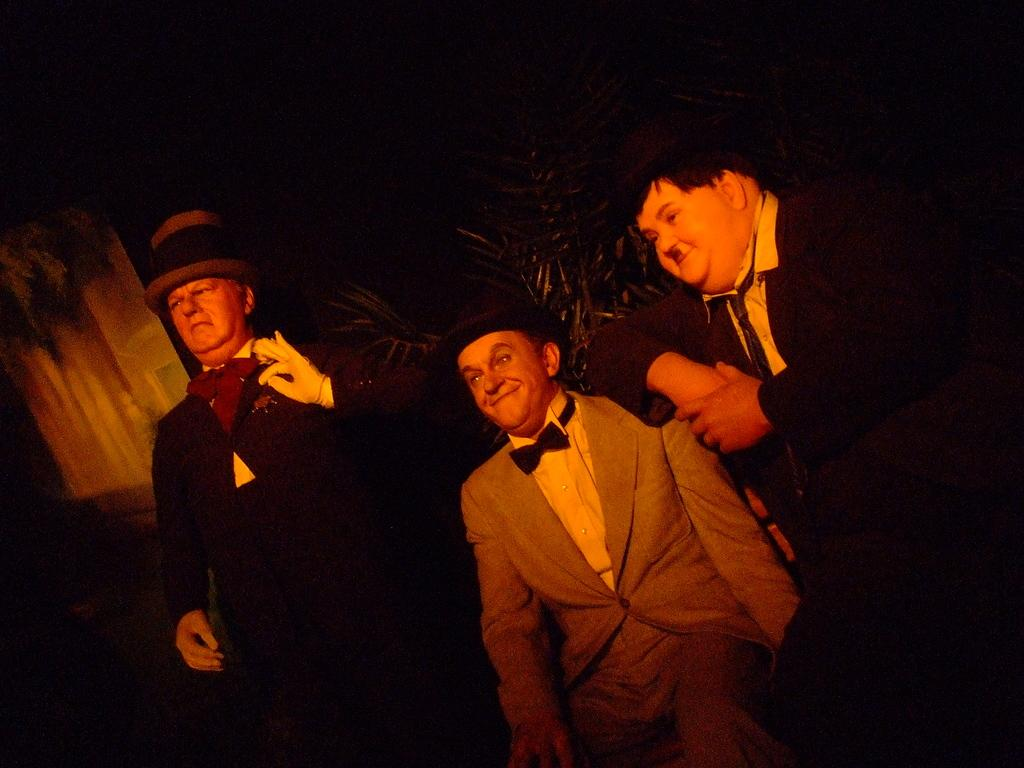How many people are in the image? There are three people in the image. What are the positions of the people in the image? The person on the left is standing, while the other two people are sitting. What can be seen in the background of the image? The background of the image is dark, and there are plants visible in the background. What type of wall can be seen in the image? There is no wall present in the image; it features three people with a dark background and visible plants. 